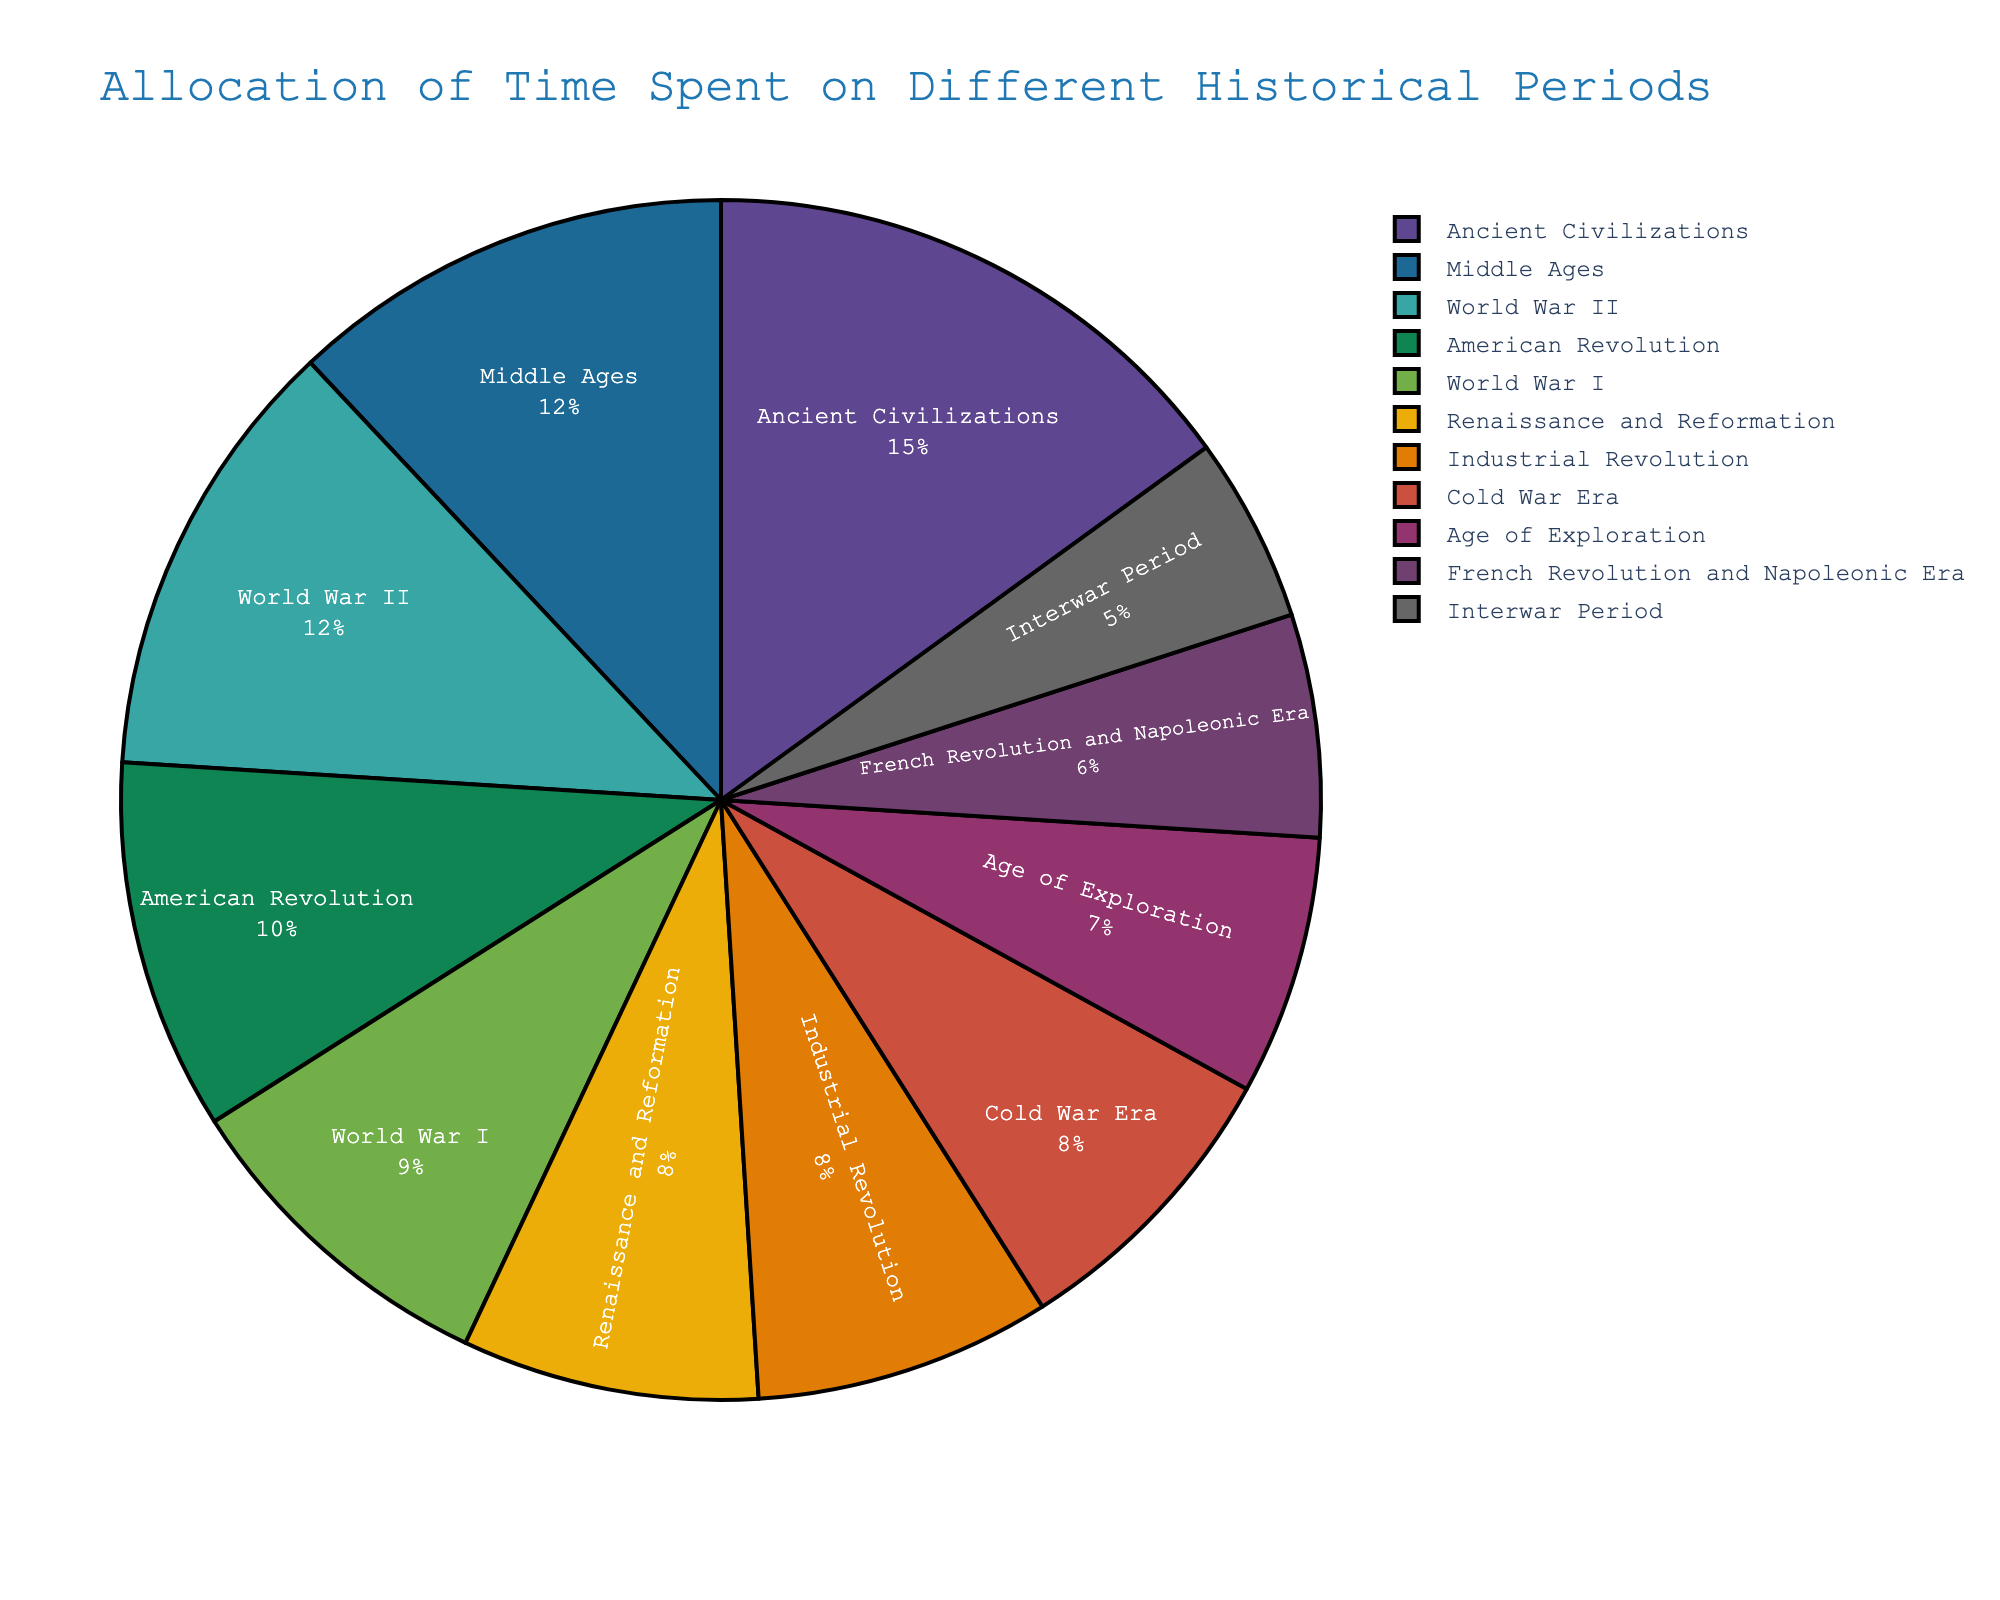Which historical period is allocated the highest percentage of time in the curriculum? The figure shows that Ancient Civilizations has the highest percentage of 15%.
Answer: Ancient Civilizations What is the total percentage of time allocated to both World Wars? Add the percentages allocated to WWI and WWII: 9% + 12% = 21%.
Answer: 21% Which historical period occupies less time than the American Revolution but more time than the Age of Exploration? The American Revolution is allocated 10%, and the Age of Exploration is allocated 7%. The Middle Ages with 12% fits this criterion.
Answer: Middle Ages Is the percentage of time allocated to the French Revolution and Napoleonic Era greater than that of the Interwar Period? The percentage for the French Revolution and Napoleonic Era is 6%, while the Interwar Period is 5%. 6% > 5%.
Answer: Yes Compare the time allocated to the Renaissance and Reformation with that of the Cold War Era. Which has more, and by how much? The Renaissance and Reformation is allocated 8%, while the Cold War Era is also allocated 8%. The difference is 0.
Answer: Equal, 0% Sum up the time allocated to periods from the Ancient Civilizations to the Industrial Revolution (inclusive). Add the percentages of Ancient Civilizations, Middle Ages, Renaissance and Reformation, Age of Exploration, American Revolution, French Revolution and Napoleonic Era, Industrial Revolution: 15% + 12% + 8% + 7% + 10% + 6% + 8% = 66%.
Answer: 66% Between the periods of the American Revolution and the French Revolution and Napoleonic Era, which has a larger share, and what is their difference? The American Revolution is allocated 10%, and the French Revolution and Napoleonic Era is allocated 6%. The difference is 10% - 6% = 4%.
Answer: American Revolution, 4% What is the average percentage of time allocated to the Interwar Period, World War I, and World War II? Add their percentages and divide by 3: (5% + 9% + 12%) / 3 = 26% / 3 ≈ 8.67%.
Answer: ≈ 8.67% Identify the periods which have an equal percentage of time allocated and specify what that percentage is. Both the Renaissance and Reformation, and the Cold War Era are allocated 8%.
Answer: Renaissance and Reformation, Cold War Era, 8% Which historical periods are allocated exactly 8% of the curriculum time? The Renaissance and Reformation, the Industrial Revolution, and the Cold War Era are each allocated 8%.
Answer: Renaissance and Reformation, Industrial Revolution, Cold War Era 